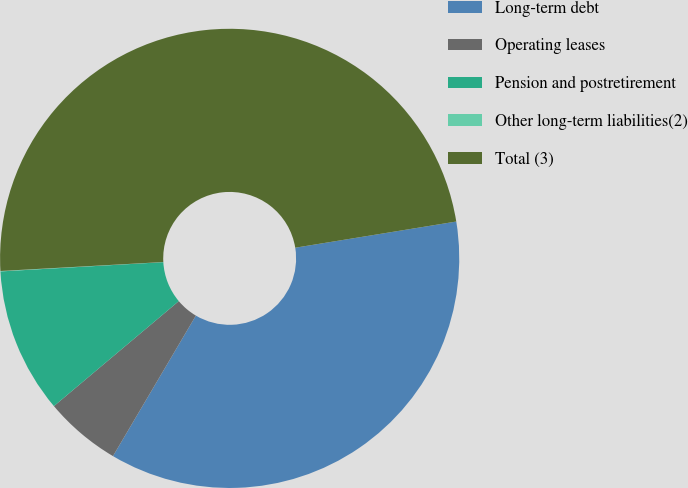Convert chart to OTSL. <chart><loc_0><loc_0><loc_500><loc_500><pie_chart><fcel>Long-term debt<fcel>Operating leases<fcel>Pension and postretirement<fcel>Other long-term liabilities(2)<fcel>Total (3)<nl><fcel>36.05%<fcel>5.39%<fcel>10.22%<fcel>0.03%<fcel>48.31%<nl></chart> 